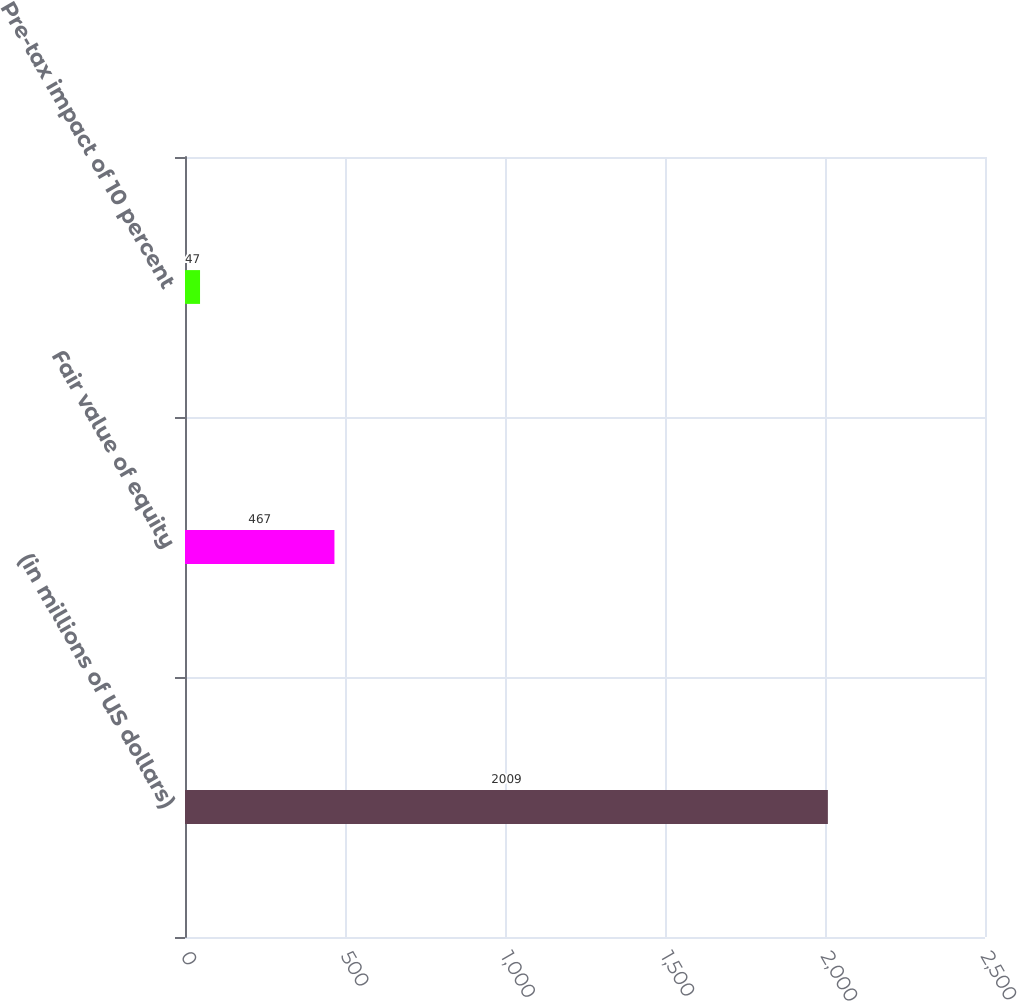<chart> <loc_0><loc_0><loc_500><loc_500><bar_chart><fcel>(in millions of US dollars)<fcel>Fair value of equity<fcel>Pre-tax impact of 10 percent<nl><fcel>2009<fcel>467<fcel>47<nl></chart> 